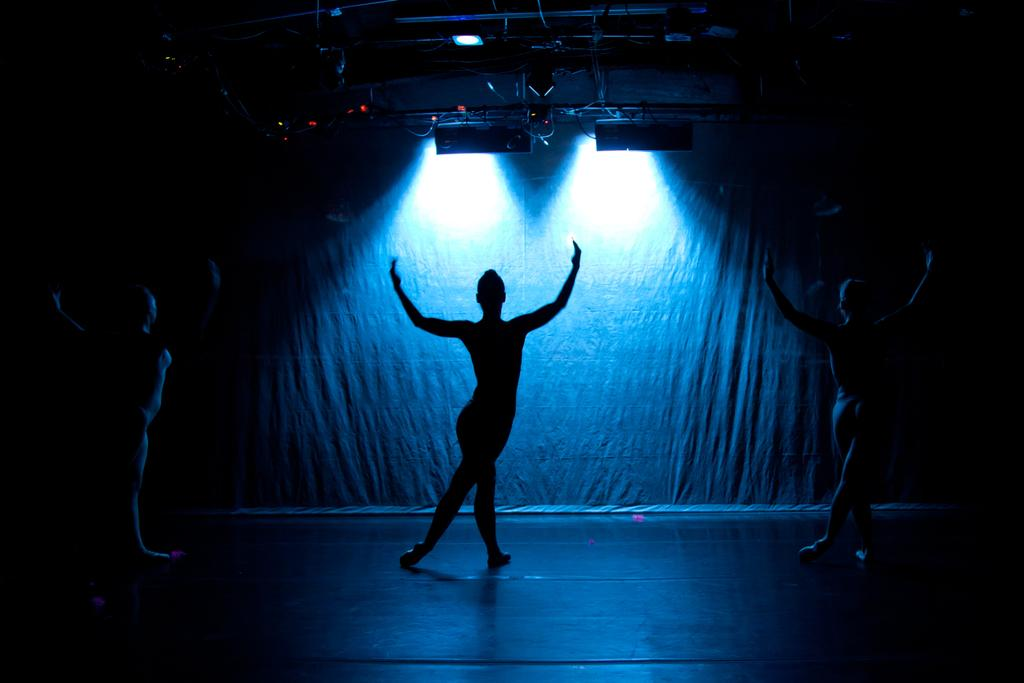What is the overall lighting condition in the image? The image is dark. What is visible on the floor in the image? There are three persons dancing on the floor. What type of objects can be seen supporting the lights in the image? There are metal rods in the image. What is attached to the metal rods in the image? There are lights attached to the metal rods. Can you see any deer in the image? No, there are no deer present in the image. What type of sheet is covering the metal rods in the image? There are no sheets covering the metal rods in the image; only lights are attached to them. 